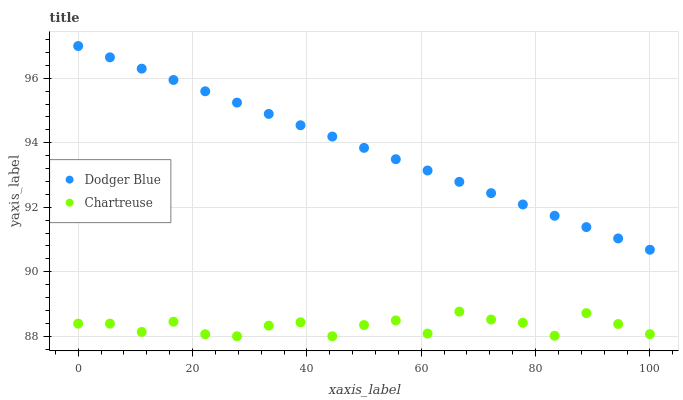Does Chartreuse have the minimum area under the curve?
Answer yes or no. Yes. Does Dodger Blue have the maximum area under the curve?
Answer yes or no. Yes. Does Dodger Blue have the minimum area under the curve?
Answer yes or no. No. Is Dodger Blue the smoothest?
Answer yes or no. Yes. Is Chartreuse the roughest?
Answer yes or no. Yes. Is Dodger Blue the roughest?
Answer yes or no. No. Does Chartreuse have the lowest value?
Answer yes or no. Yes. Does Dodger Blue have the lowest value?
Answer yes or no. No. Does Dodger Blue have the highest value?
Answer yes or no. Yes. Is Chartreuse less than Dodger Blue?
Answer yes or no. Yes. Is Dodger Blue greater than Chartreuse?
Answer yes or no. Yes. Does Chartreuse intersect Dodger Blue?
Answer yes or no. No. 